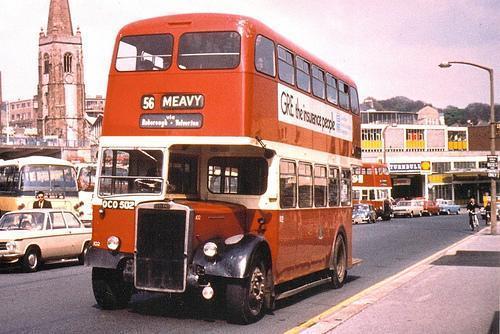How many levels does the bus have?
Give a very brief answer. 2. 